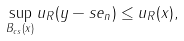Convert formula to latex. <formula><loc_0><loc_0><loc_500><loc_500>\sup _ { B _ { c s } ( x ) } u _ { R } ( y - s e _ { n } ) \leq u _ { R } ( x ) ,</formula> 